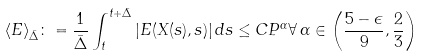<formula> <loc_0><loc_0><loc_500><loc_500>\langle E \rangle _ { \bar { \Delta } } \colon = \frac { 1 } { \bar { \Delta } } \int _ { t } ^ { t + \bar { \Delta } } | E ( X ( s ) , s ) | \, d s \leq C P ^ { \alpha } \forall \, \alpha \in \left ( \frac { 5 - \epsilon } { 9 } , \frac { 2 } { 3 } \right )</formula> 